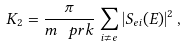<formula> <loc_0><loc_0><loc_500><loc_500>K _ { 2 } = \frac { \pi } { m _ { \ } p { r } k } \sum _ { i \neq e } | S _ { e i } ( E ) | ^ { 2 } \, ,</formula> 